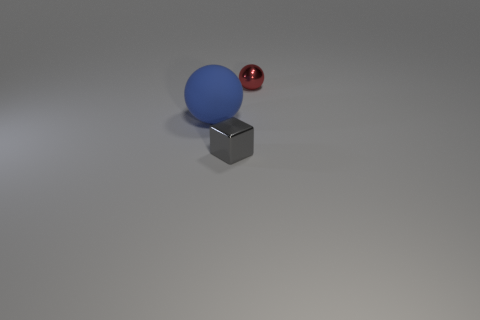How many other things are the same material as the tiny block?
Your answer should be compact. 1. Is the number of small gray objects in front of the gray block the same as the number of small gray shiny blocks?
Make the answer very short. No. Is the size of the gray shiny cube the same as the ball that is on the left side of the small block?
Offer a very short reply. No. There is a small thing to the right of the gray metallic object; what shape is it?
Keep it short and to the point. Sphere. Is there any other thing that is the same shape as the large rubber object?
Offer a terse response. Yes. Is there a big red shiny object?
Make the answer very short. No. Does the metallic object behind the large blue thing have the same size as the metallic thing that is in front of the matte ball?
Make the answer very short. Yes. There is a object that is both left of the red shiny thing and behind the tiny gray object; what is its material?
Provide a succinct answer. Rubber. What number of large matte objects are left of the big thing?
Provide a short and direct response. 0. Are there any other things that have the same size as the matte object?
Ensure brevity in your answer.  No. 